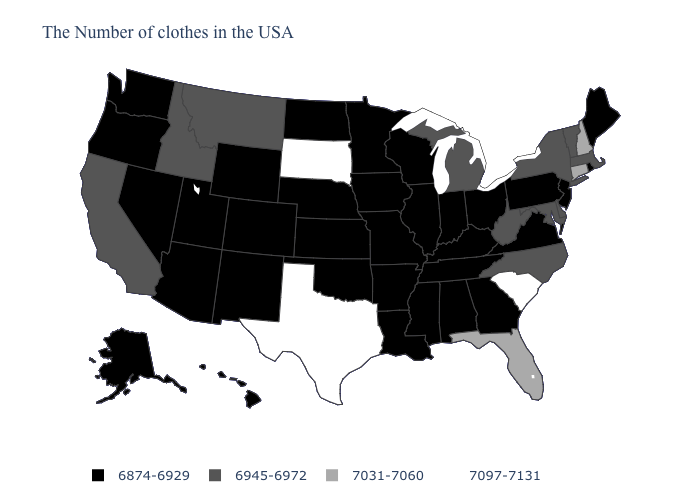Name the states that have a value in the range 7097-7131?
Concise answer only. South Carolina, Texas, South Dakota. What is the value of West Virginia?
Quick response, please. 6945-6972. Does North Dakota have a higher value than Connecticut?
Give a very brief answer. No. What is the value of North Carolina?
Quick response, please. 6945-6972. Does Oklahoma have the same value as Nebraska?
Give a very brief answer. Yes. Name the states that have a value in the range 6874-6929?
Short answer required. Maine, Rhode Island, New Jersey, Pennsylvania, Virginia, Ohio, Georgia, Kentucky, Indiana, Alabama, Tennessee, Wisconsin, Illinois, Mississippi, Louisiana, Missouri, Arkansas, Minnesota, Iowa, Kansas, Nebraska, Oklahoma, North Dakota, Wyoming, Colorado, New Mexico, Utah, Arizona, Nevada, Washington, Oregon, Alaska, Hawaii. What is the value of Virginia?
Be succinct. 6874-6929. What is the value of Oklahoma?
Concise answer only. 6874-6929. What is the value of Ohio?
Short answer required. 6874-6929. How many symbols are there in the legend?
Quick response, please. 4. Which states hav the highest value in the South?
Concise answer only. South Carolina, Texas. What is the highest value in states that border Montana?
Be succinct. 7097-7131. Does Arizona have the lowest value in the USA?
Give a very brief answer. Yes. Name the states that have a value in the range 7031-7060?
Quick response, please. New Hampshire, Connecticut, Florida. Among the states that border Texas , which have the lowest value?
Be succinct. Louisiana, Arkansas, Oklahoma, New Mexico. 